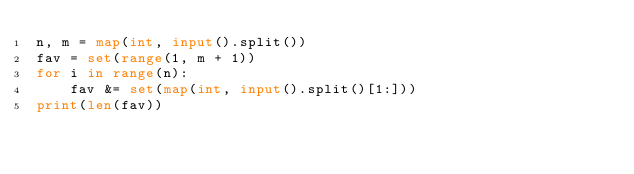<code> <loc_0><loc_0><loc_500><loc_500><_Python_>n, m = map(int, input().split())
fav = set(range(1, m + 1))
for i in range(n):
    fav &= set(map(int, input().split()[1:]))
print(len(fav))
</code> 